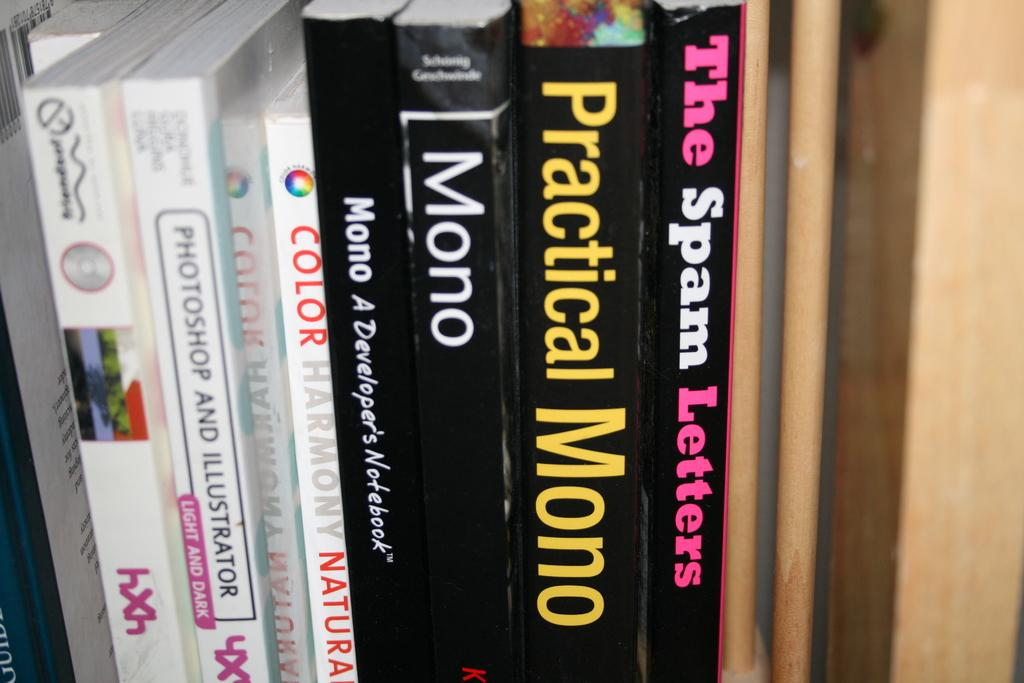<image>
Relay a brief, clear account of the picture shown. several books on a shelf including The Spam Letters 